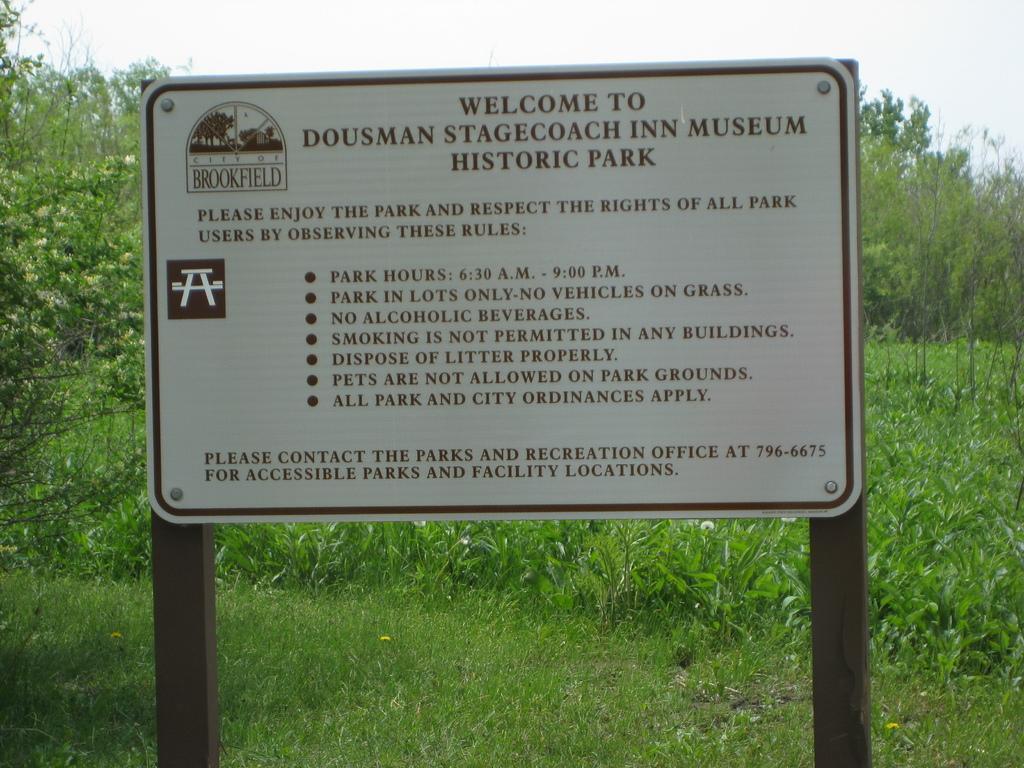Could you give a brief overview of what you see in this image? In this image I see a white board on which there are words written and I see the logo over here and this board is on the poles. In the background I see the grass, plants, trees and the sky. 